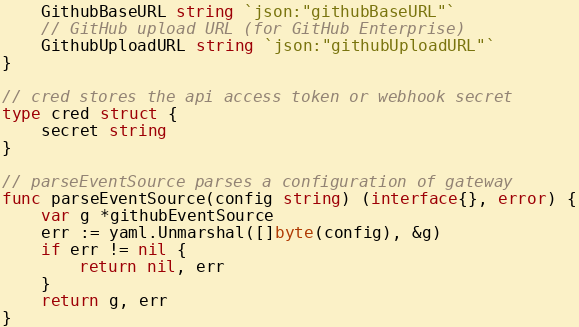<code> <loc_0><loc_0><loc_500><loc_500><_Go_>	GithubBaseURL string `json:"githubBaseURL"`
	// GitHub upload URL (for GitHub Enterprise)
	GithubUploadURL string `json:"githubUploadURL"`
}

// cred stores the api access token or webhook secret
type cred struct {
	secret string
}

// parseEventSource parses a configuration of gateway
func parseEventSource(config string) (interface{}, error) {
	var g *githubEventSource
	err := yaml.Unmarshal([]byte(config), &g)
	if err != nil {
		return nil, err
	}
	return g, err
}
</code> 